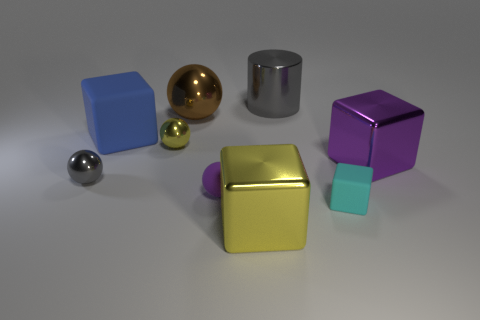Subtract 1 cubes. How many cubes are left? 3 Subtract all balls. How many objects are left? 5 Subtract 0 green balls. How many objects are left? 9 Subtract all tiny spheres. Subtract all tiny gray cylinders. How many objects are left? 6 Add 2 yellow metallic spheres. How many yellow metallic spheres are left? 3 Add 4 gray spheres. How many gray spheres exist? 5 